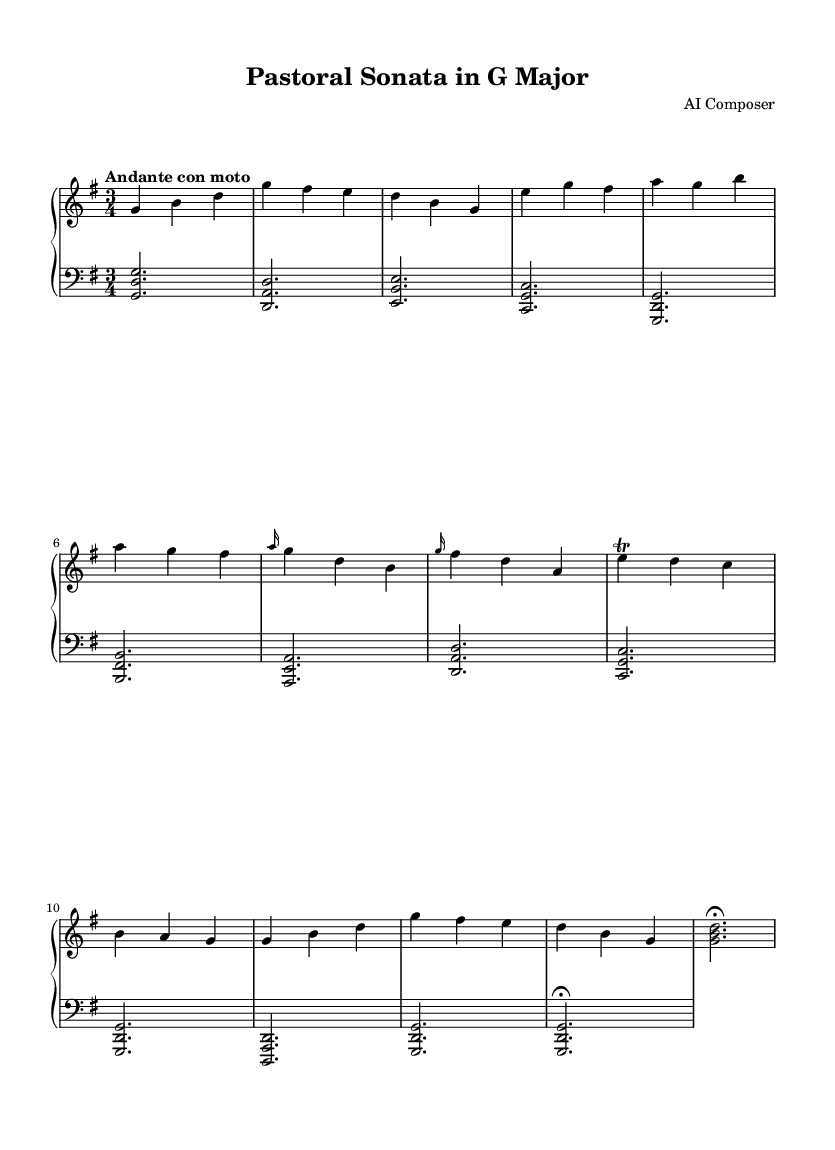What is the key signature of this music? The key signature is G major, which has one sharp (F#). This can be identified by looking at the key signature located at the beginning of the staff, indicating G major.
Answer: G major What is the time signature of this music? The time signature is 3/4, which can be found displayed at the beginning of the sheet music. This means there are three beats per measure, and the quarter note gets one beat.
Answer: 3/4 What is the tempo marking for this piece? The tempo marking is "Andante con moto." This can be seen indicated at the start of the piece, specifying the speed and style of play.
Answer: Andante con moto How many measures are present in the upper staff? There are ten measures in the upper staff, which can be counted by observing the division of the music into segments, each separated by vertical bar lines.
Answer: 10 What type of harmony is primarily used in the lower staff? The lower staff primarily uses chordal harmony, represented by the notation of stacked notes that create chords throughout the piece. This structure supports the melodic content above.
Answer: Chordal harmony Which musical form is reflected in this sonata composition? The composition reflects a sonata form, which includes the exposition, development, and recapitulation sections, clearly visible through the structure and labeling in the sheet music.
Answer: Sonata form What is the mood conveyed by the tempo and key signature combined? The mood conveyed is serene, fostered by the Andante con moto tempo along with the nature of G major, which typically evokes a peaceful and pastoral feeling reminiscent of farmland and open fields.
Answer: Serene 